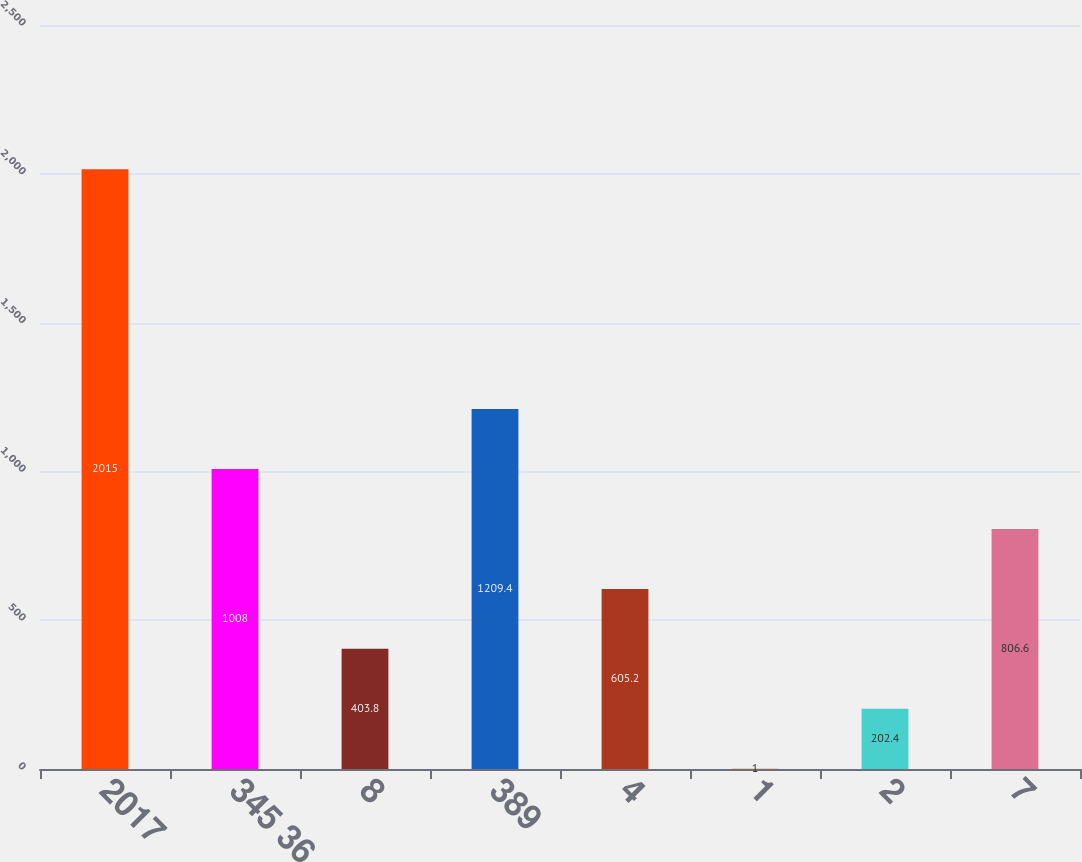<chart> <loc_0><loc_0><loc_500><loc_500><bar_chart><fcel>2017<fcel>345 36<fcel>8<fcel>389<fcel>4<fcel>1<fcel>2<fcel>7<nl><fcel>2015<fcel>1008<fcel>403.8<fcel>1209.4<fcel>605.2<fcel>1<fcel>202.4<fcel>806.6<nl></chart> 